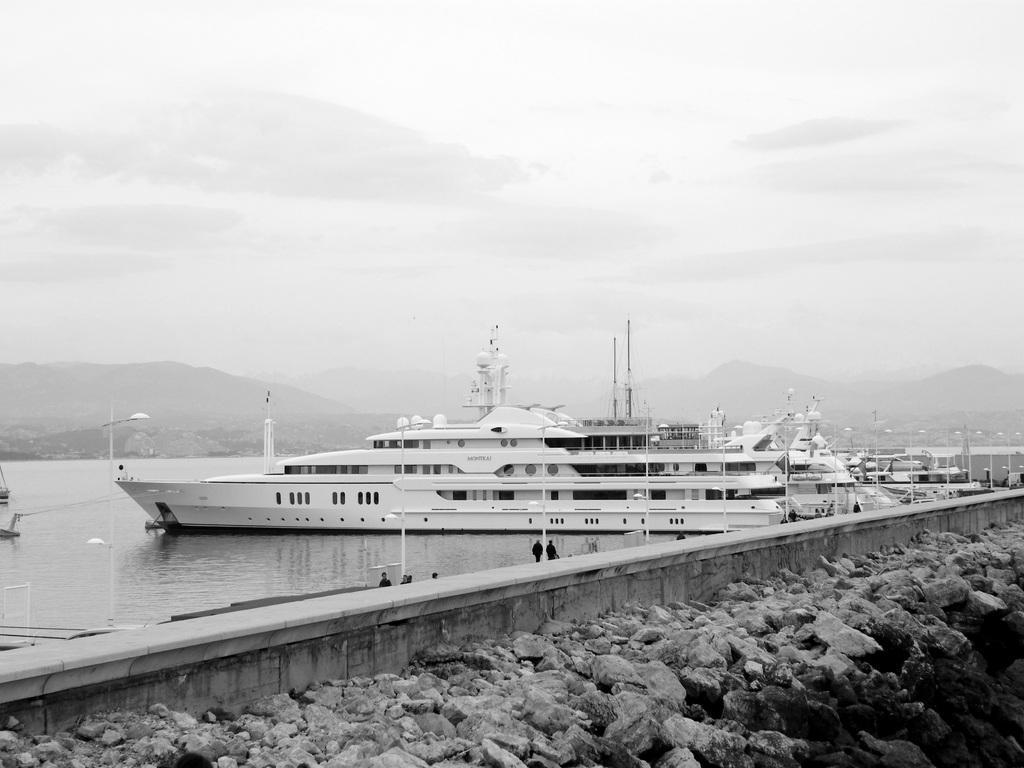In one or two sentences, can you explain what this image depicts? In this image at the bottom there are some rocks, and in the center there is wall and some people. In the background there is a river, and in the river there are some ships. In the ships there are some poles, towers, and some objects. And in the background there are some mountains, at the top there is sky and also we could see some poles and lights. 